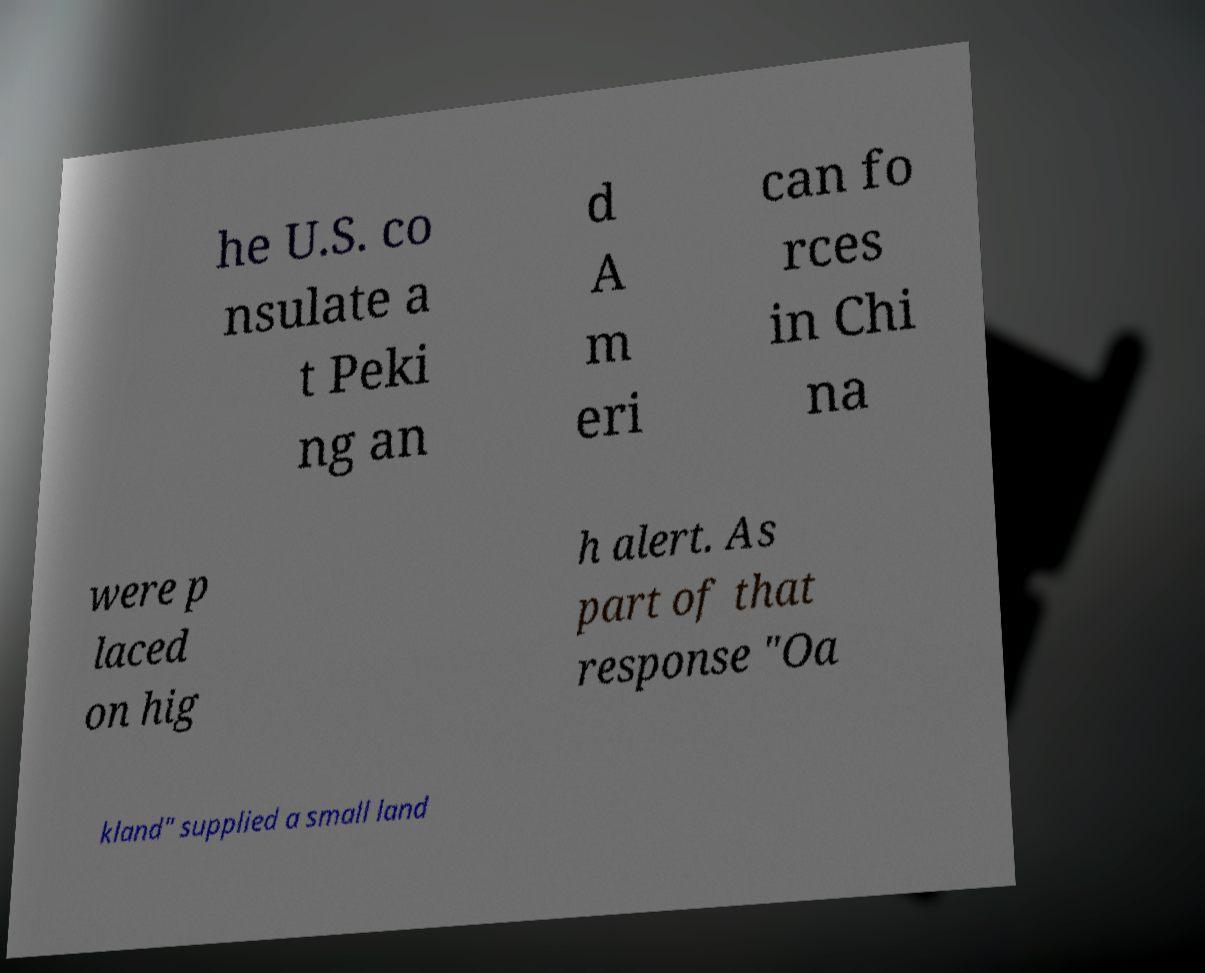Please identify and transcribe the text found in this image. he U.S. co nsulate a t Peki ng an d A m eri can fo rces in Chi na were p laced on hig h alert. As part of that response "Oa kland" supplied a small land 